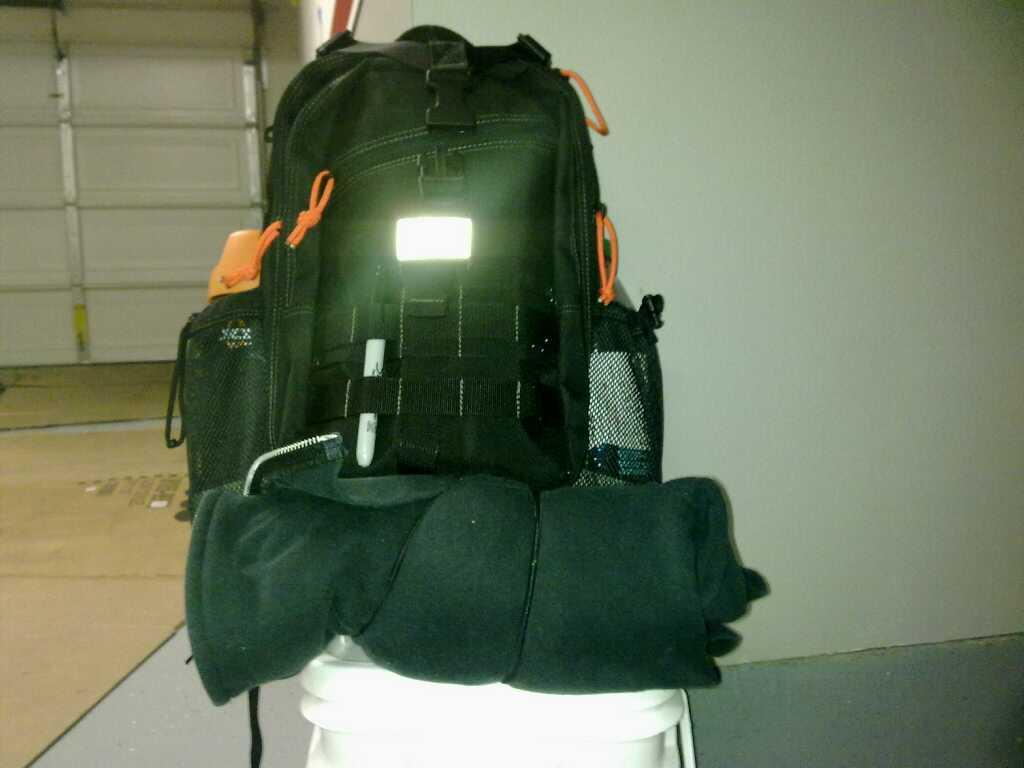What object is covered by a blanket in the image? There is a black bag in the image that is under a blanket. What type of furniture is present in the image? There is a table in the image. What color is the background of the image? The background of the image is a white wall. What type of hose is connected to the table in the image? There is no hose connected to the table in the image. What angle is the black bag positioned at in the image? The angle of the black bag cannot be determined from the image, as it is covered by a blanket. 